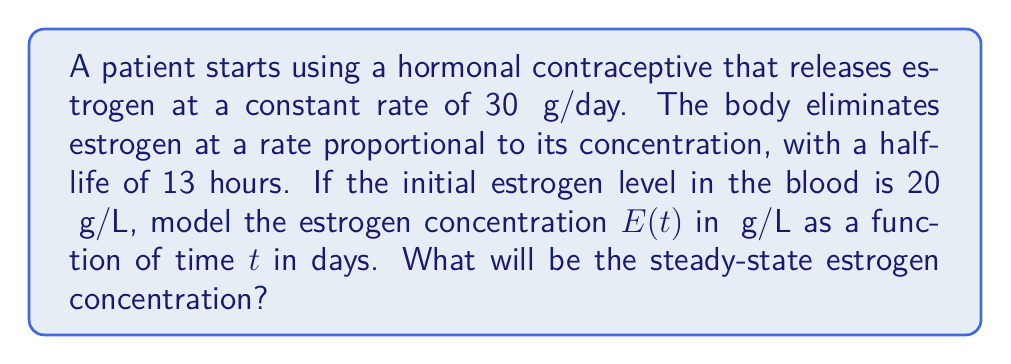Teach me how to tackle this problem. Let's approach this problem step-by-step using a first-order differential equation:

1) The rate of change of estrogen concentration can be modeled as:

   $$\frac{dE}{dt} = \text{Rate of Input} - \text{Rate of Elimination}$$

2) The rate of input is constant at 30 μg/day. Let's assume the blood volume is 5L for simplicity. So, the input rate in terms of concentration is:

   $$\text{Rate of Input} = \frac{30 \text{ μg/day}}{5 \text{ L}} = 6 \text{ μg/L/day}$$

3) The elimination rate is proportional to the concentration. Let $k$ be the elimination rate constant:

   $$\text{Rate of Elimination} = kE$$

4) Now our differential equation is:

   $$\frac{dE}{dt} = 6 - kE$$

5) To find $k$, we use the half-life formula:

   $$t_{1/2} = \frac{\ln(2)}{k}$$
   $$k = \frac{\ln(2)}{t_{1/2}} = \frac{\ln(2)}{13/24} \approx 1.28 \text{ day}^{-1}$$

6) Our final differential equation is:

   $$\frac{dE}{dt} = 6 - 1.28E$$

7) The steady-state occurs when $\frac{dE}{dt} = 0$:

   $$0 = 6 - 1.28E_{ss}$$
   $$E_{ss} = \frac{6}{1.28} \approx 4.69 \text{ μg/L}$$

Therefore, the steady-state estrogen concentration will be approximately 4.69 μg/L.
Answer: The steady-state estrogen concentration is approximately 4.69 μg/L. 